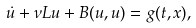Convert formula to latex. <formula><loc_0><loc_0><loc_500><loc_500>\dot { u } + \nu L u + B ( u , u ) = g ( t , x ) ,</formula> 